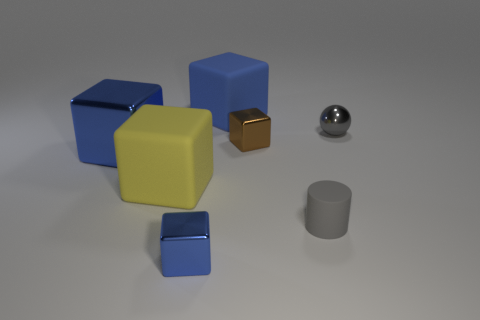There is a matte object that is the same color as the big shiny block; what size is it?
Provide a succinct answer. Large. How many other things are the same color as the tiny matte cylinder?
Keep it short and to the point. 1. What material is the big yellow object that is the same shape as the brown thing?
Ensure brevity in your answer.  Rubber. How many other gray spheres are the same size as the ball?
Give a very brief answer. 0. Is there a blue metal thing that is behind the big block that is left of the yellow cube?
Keep it short and to the point. No. What number of brown objects are metallic balls or cylinders?
Ensure brevity in your answer.  0. What is the color of the large shiny object?
Make the answer very short. Blue. There is a yellow cube that is made of the same material as the small cylinder; what size is it?
Your response must be concise. Large. What number of other blue things have the same shape as the small blue metal thing?
Offer a terse response. 2. Is there any other thing that is the same size as the brown thing?
Offer a terse response. Yes. 